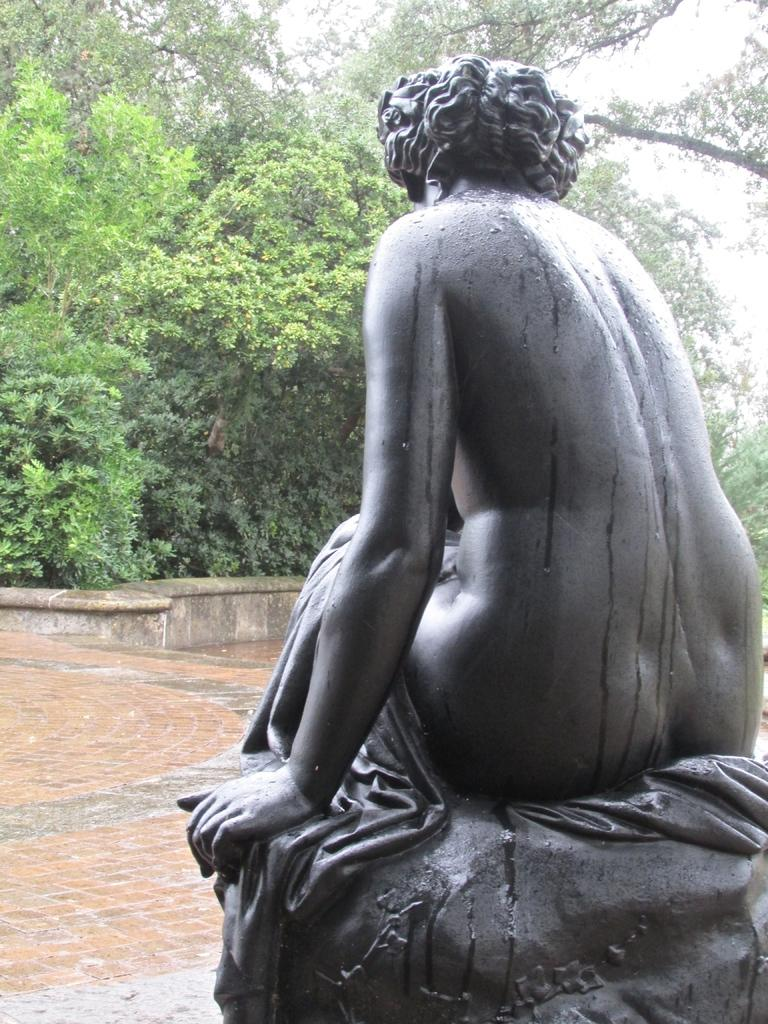What is the main subject in the foreground of the image? There is a statue in the foreground of the image. What can be seen in the background of the image? There are trees in the background of the image. What type of crib is visible in the image? There is no crib present in the image. What route is the statue taking in the image? The statue is not taking a route, as it is a stationary object in the image. 